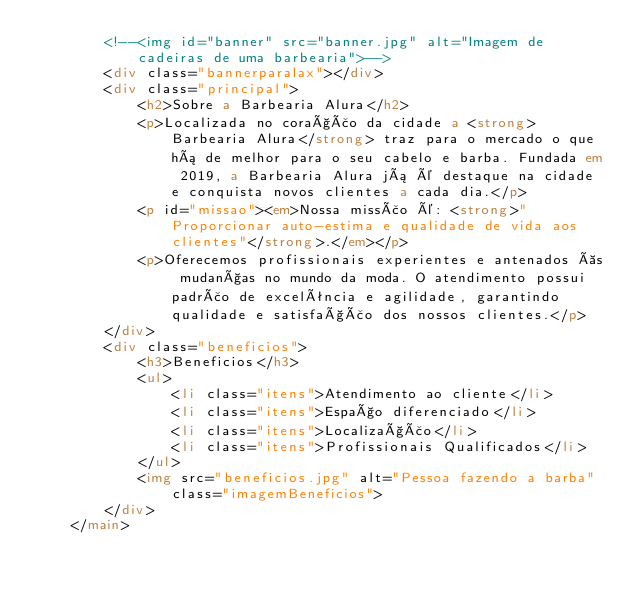Convert code to text. <code><loc_0><loc_0><loc_500><loc_500><_HTML_>        <!--<img id="banner" src="banner.jpg" alt="Imagem de cadeiras de uma barbearia">-->
        <div class="bannerparalax"></div>
        <div class="principal">
            <h2>Sobre a Barbearia Alura</h2>
            <p>Localizada no coração da cidade a <strong>Barbearia Alura</strong> traz para o mercado o que há de melhor para o seu cabelo e barba. Fundada em 2019, a Barbearia Alura já é destaque na cidade e conquista novos clientes a cada dia.</p>
            <p id="missao"><em>Nossa missão é: <strong>"Proporcionar auto-estima e qualidade de vida aos clientes"</strong>.</em></p>
            <p>Oferecemos profissionais experientes e antenados às mudanças no mundo da moda. O atendimento possui padrão de excelência e agilidade, garantindo qualidade e satisfação dos nossos clientes.</p>
        </div>
        <div class="beneficios">
            <h3>Beneficios</h3>
            <ul>
                <li class="itens">Atendimento ao cliente</li>
                <li class="itens">Espaço diferenciado</li>
                <li class="itens">Localização</li>
                <li class="itens">Profissionais Qualificados</li>
            </ul>
            <img src="beneficios.jpg" alt="Pessoa fazendo a barba" class="imagemBeneficios">
        </div>
    </main></code> 